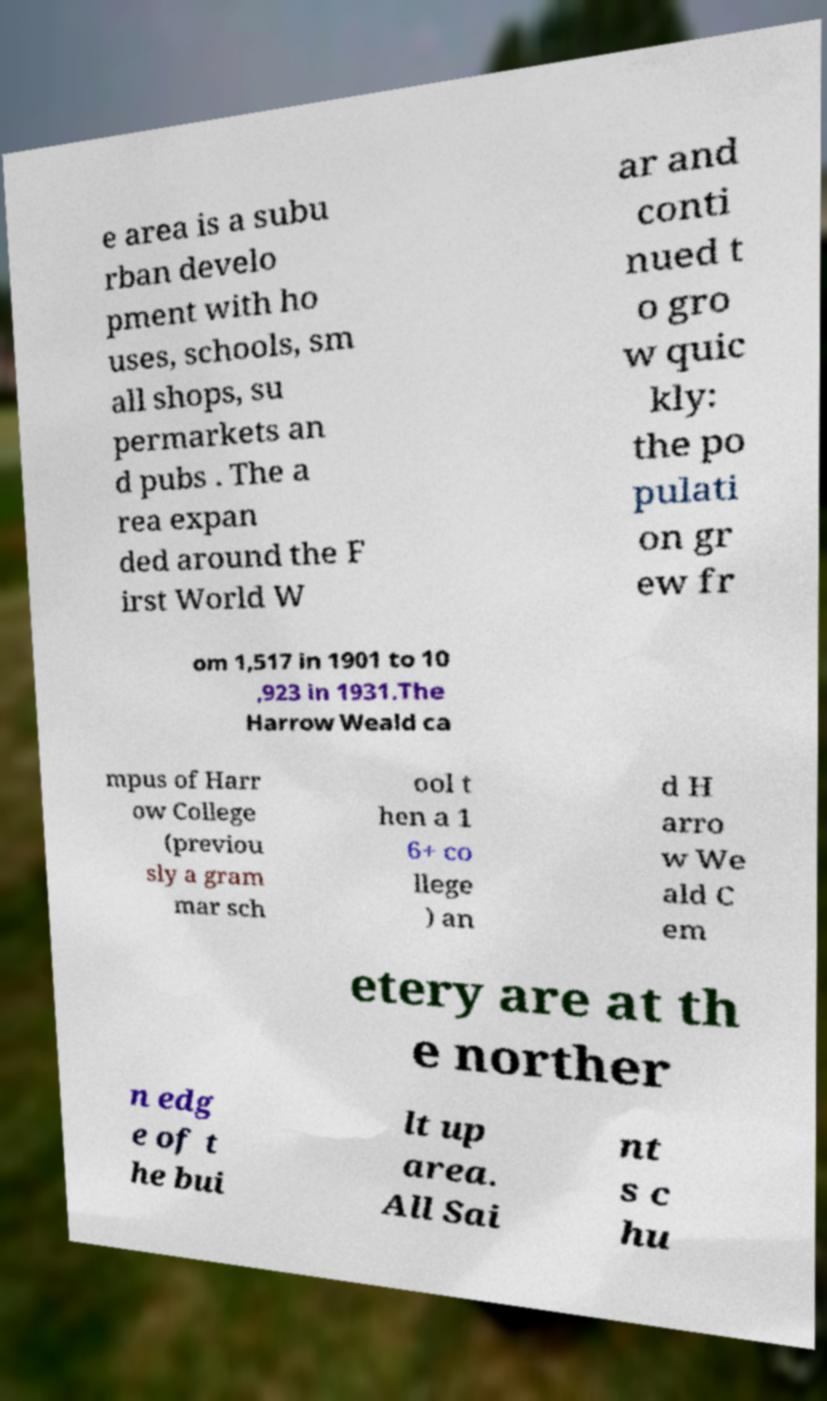Please identify and transcribe the text found in this image. e area is a subu rban develo pment with ho uses, schools, sm all shops, su permarkets an d pubs . The a rea expan ded around the F irst World W ar and conti nued t o gro w quic kly: the po pulati on gr ew fr om 1,517 in 1901 to 10 ,923 in 1931.The Harrow Weald ca mpus of Harr ow College (previou sly a gram mar sch ool t hen a 1 6+ co llege ) an d H arro w We ald C em etery are at th e norther n edg e of t he bui lt up area. All Sai nt s c hu 